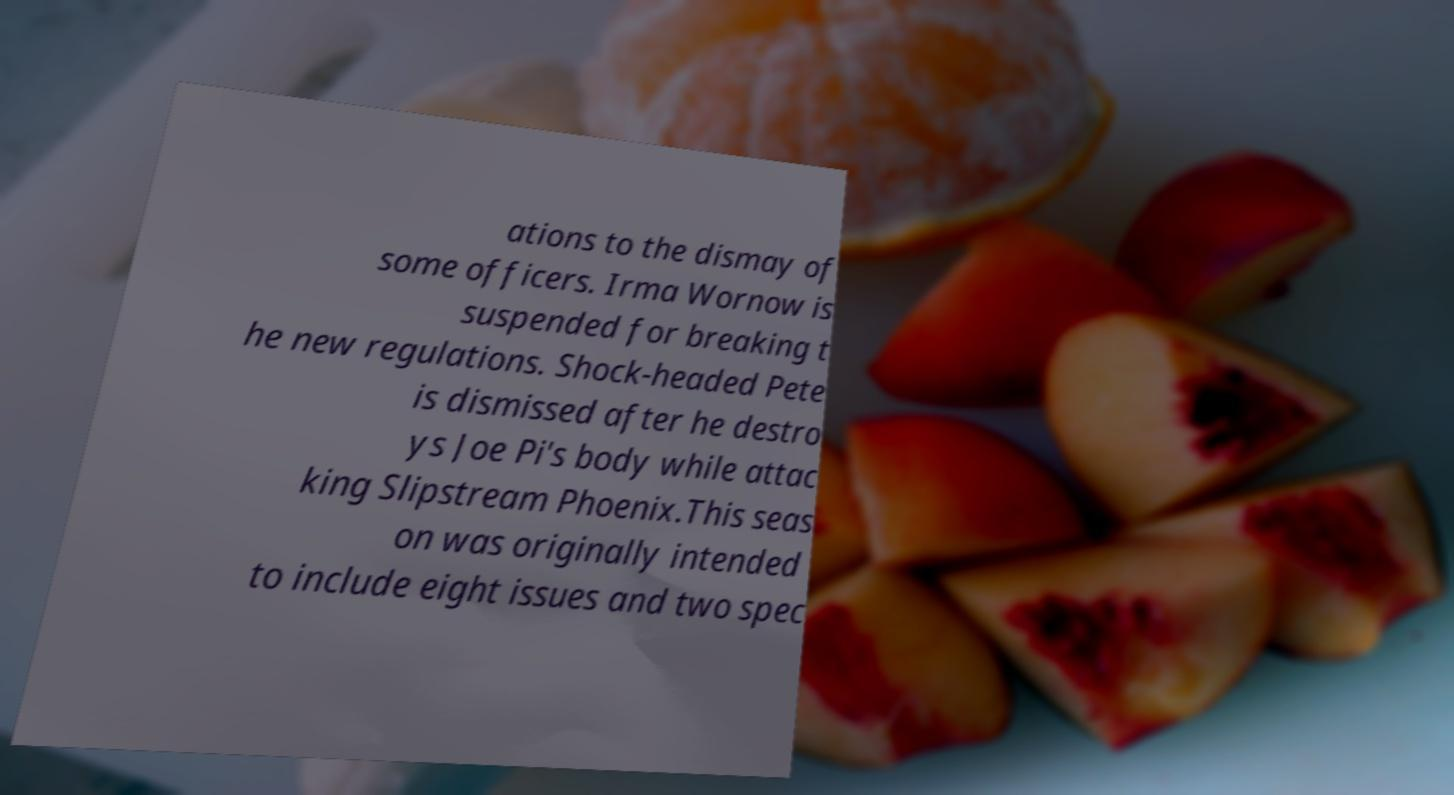There's text embedded in this image that I need extracted. Can you transcribe it verbatim? ations to the dismay of some officers. Irma Wornow is suspended for breaking t he new regulations. Shock-headed Pete is dismissed after he destro ys Joe Pi's body while attac king Slipstream Phoenix.This seas on was originally intended to include eight issues and two spec 